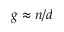<formula> <loc_0><loc_0><loc_500><loc_500>g \approx n / d</formula> 